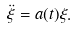<formula> <loc_0><loc_0><loc_500><loc_500>\ddot { \xi } = a ( t ) \xi .</formula> 